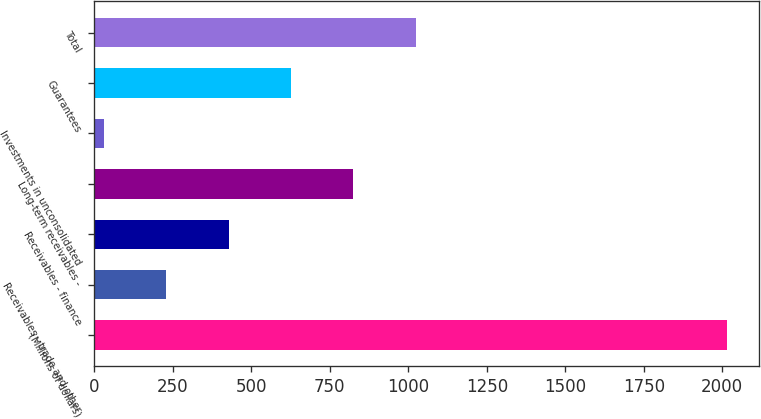Convert chart to OTSL. <chart><loc_0><loc_0><loc_500><loc_500><bar_chart><fcel>(Millions of dollars)<fcel>Receivables - trade and other<fcel>Receivables - finance<fcel>Long-term receivables -<fcel>Investments in unconsolidated<fcel>Guarantees<fcel>Total<nl><fcel>2016<fcel>229.5<fcel>428<fcel>825<fcel>31<fcel>626.5<fcel>1023.5<nl></chart> 